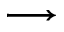<formula> <loc_0><loc_0><loc_500><loc_500>\longrightarrow</formula> 